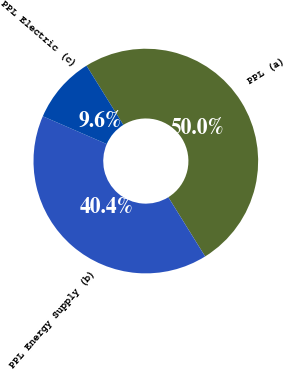Convert chart to OTSL. <chart><loc_0><loc_0><loc_500><loc_500><pie_chart><fcel>PPL (a)<fcel>PPL Energy Supply (b)<fcel>PPL Electric (c)<nl><fcel>50.0%<fcel>40.38%<fcel>9.62%<nl></chart> 